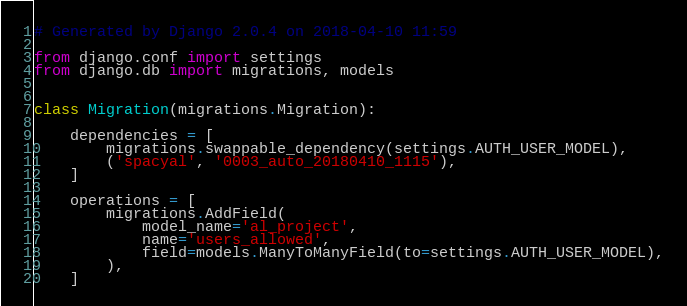Convert code to text. <code><loc_0><loc_0><loc_500><loc_500><_Python_># Generated by Django 2.0.4 on 2018-04-10 11:59

from django.conf import settings
from django.db import migrations, models


class Migration(migrations.Migration):

    dependencies = [
        migrations.swappable_dependency(settings.AUTH_USER_MODEL),
        ('spacyal', '0003_auto_20180410_1115'),
    ]

    operations = [
        migrations.AddField(
            model_name='al_project',
            name='users_allowed',
            field=models.ManyToManyField(to=settings.AUTH_USER_MODEL),
        ),
    ]
</code> 